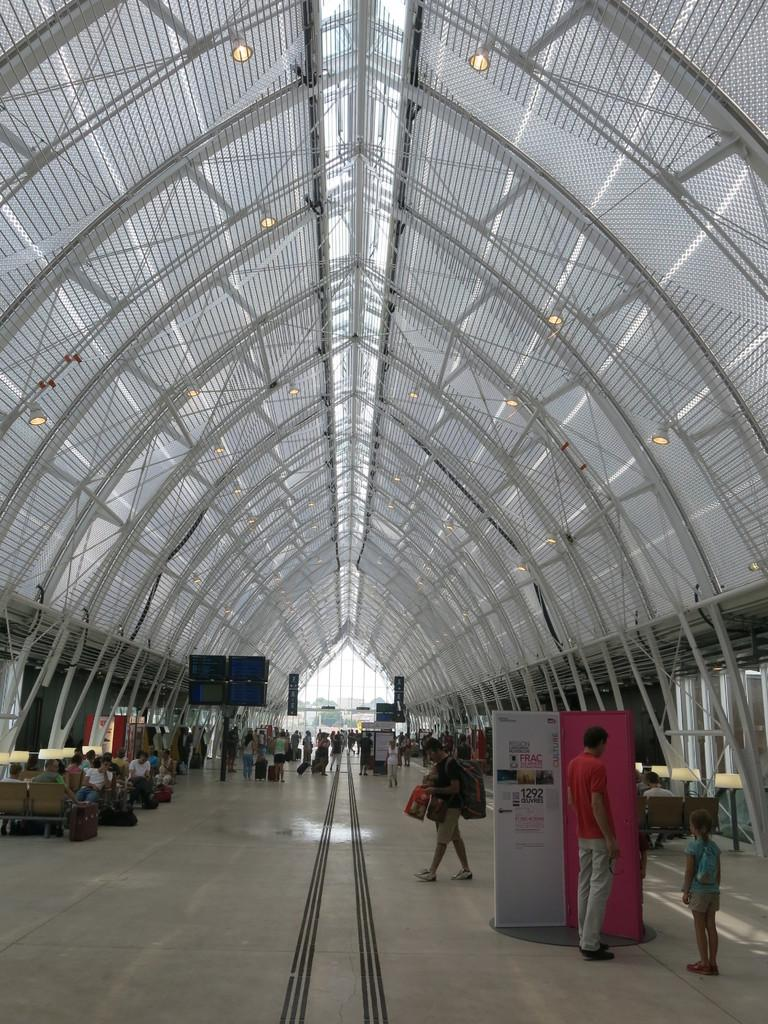How many people are in the image? There is a group of people in the image. What are some of the people doing in the image? Some people are standing, some are walking, and some are sitting on chairs. What can be seen in the background of the image? There are metal rods and lights in the background of the image. What type of comfort can be seen on the people's flesh in the image? There is no mention of comfort or flesh in the image; it simply shows people standing, walking, and sitting. 